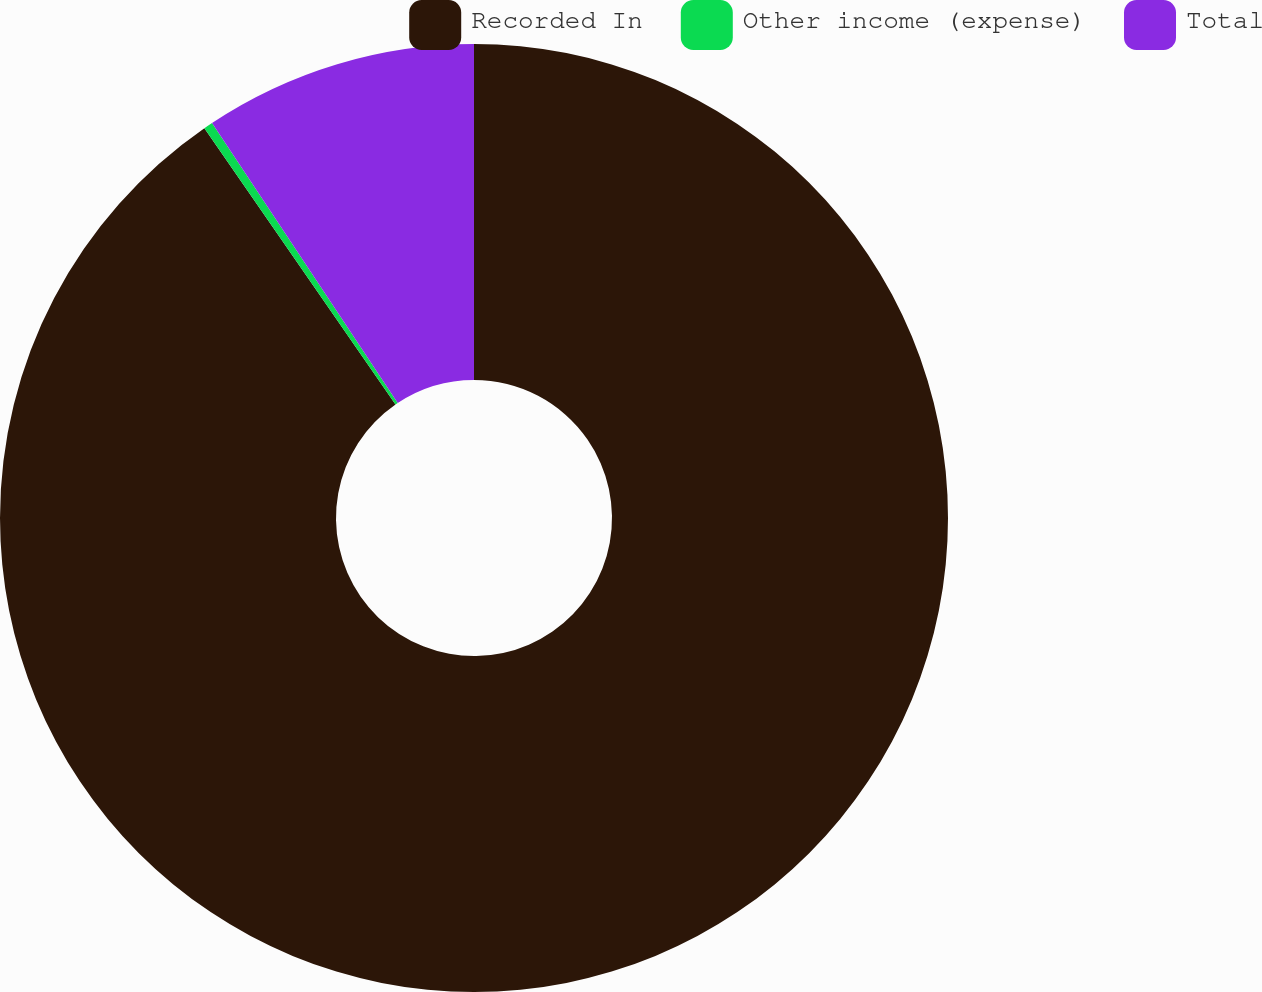<chart> <loc_0><loc_0><loc_500><loc_500><pie_chart><fcel>Recorded In<fcel>Other income (expense)<fcel>Total<nl><fcel>90.37%<fcel>0.31%<fcel>9.32%<nl></chart> 